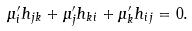Convert formula to latex. <formula><loc_0><loc_0><loc_500><loc_500>\mu ^ { \prime } _ { i } h _ { j k } + \mu ^ { \prime } _ { j } h _ { k i } + \mu ^ { \prime } _ { k } h _ { i j } = 0 .</formula> 